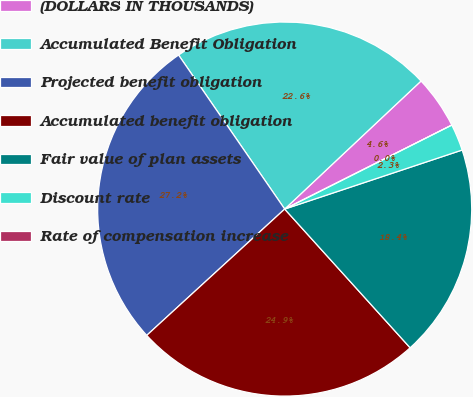Convert chart. <chart><loc_0><loc_0><loc_500><loc_500><pie_chart><fcel>(DOLLARS IN THOUSANDS)<fcel>Accumulated Benefit Obligation<fcel>Projected benefit obligation<fcel>Accumulated benefit obligation<fcel>Fair value of plan assets<fcel>Discount rate<fcel>Rate of compensation increase<nl><fcel>4.59%<fcel>22.6%<fcel>27.2%<fcel>24.9%<fcel>18.41%<fcel>2.3%<fcel>0.0%<nl></chart> 